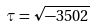<formula> <loc_0><loc_0><loc_500><loc_500>\tau = \sqrt { - 3 5 0 2 }</formula> 